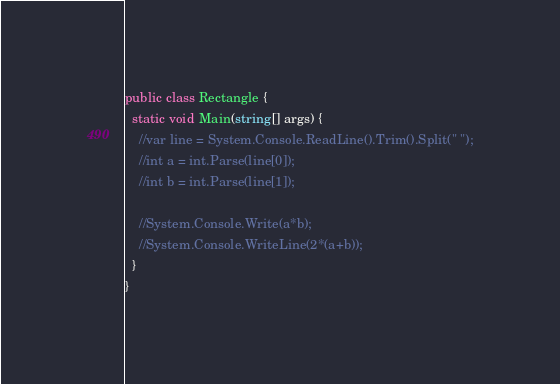<code> <loc_0><loc_0><loc_500><loc_500><_C#_>public class Rectangle {
  static void Main(string[] args) {
    //var line = System.Console.ReadLine().Trim().Split(" ");
    //int a = int.Parse(line[0]);
    //int b = int.Parse(line[1]);

    //System.Console.Write(a*b);
    //System.Console.WriteLine(2*(a+b));
  }
}</code> 